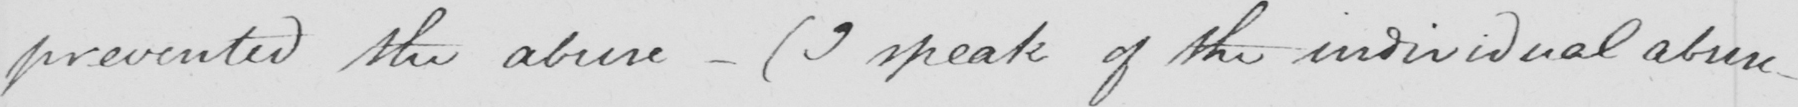What is written in this line of handwriting? prevented the abuse  _   ( I speak of the individual abuse 